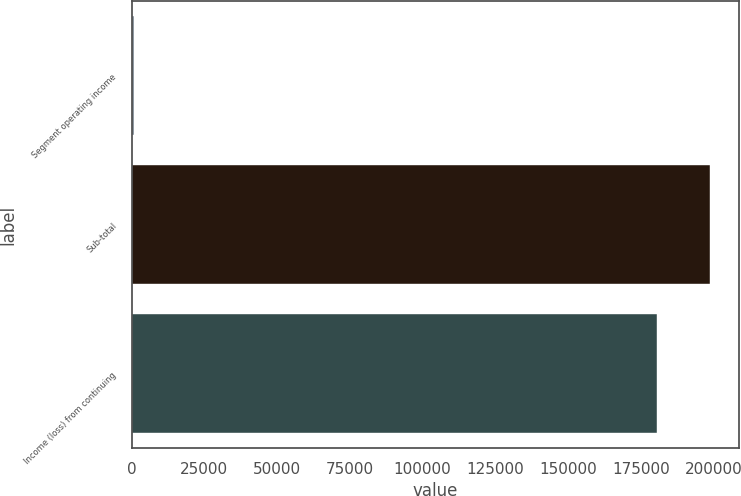<chart> <loc_0><loc_0><loc_500><loc_500><bar_chart><fcel>Segment operating income<fcel>Sub-total<fcel>Income (loss) from continuing<nl><fcel>874<fcel>198860<fcel>180702<nl></chart> 